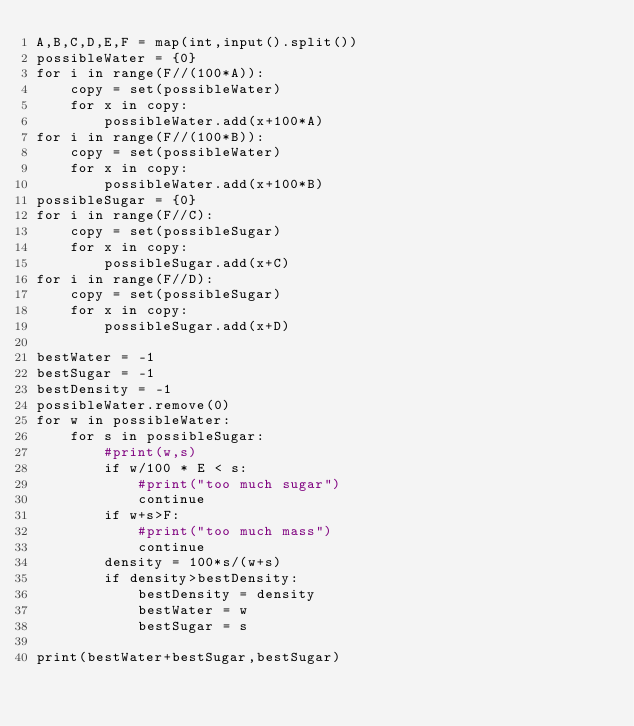<code> <loc_0><loc_0><loc_500><loc_500><_Python_>A,B,C,D,E,F = map(int,input().split())
possibleWater = {0}
for i in range(F//(100*A)):
    copy = set(possibleWater)
    for x in copy:
        possibleWater.add(x+100*A)
for i in range(F//(100*B)):
    copy = set(possibleWater)
    for x in copy:
        possibleWater.add(x+100*B)
possibleSugar = {0}
for i in range(F//C):
    copy = set(possibleSugar)
    for x in copy:
        possibleSugar.add(x+C)
for i in range(F//D):
    copy = set(possibleSugar)
    for x in copy:
        possibleSugar.add(x+D)

bestWater = -1
bestSugar = -1
bestDensity = -1
possibleWater.remove(0)
for w in possibleWater:
    for s in possibleSugar:
        #print(w,s)
        if w/100 * E < s:
            #print("too much sugar")
            continue
        if w+s>F:
            #print("too much mass")
            continue
        density = 100*s/(w+s)
        if density>bestDensity:
            bestDensity = density
            bestWater = w
            bestSugar = s

print(bestWater+bestSugar,bestSugar)
</code> 